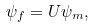Convert formula to latex. <formula><loc_0><loc_0><loc_500><loc_500>\psi _ { f } = U \psi _ { m } ,</formula> 